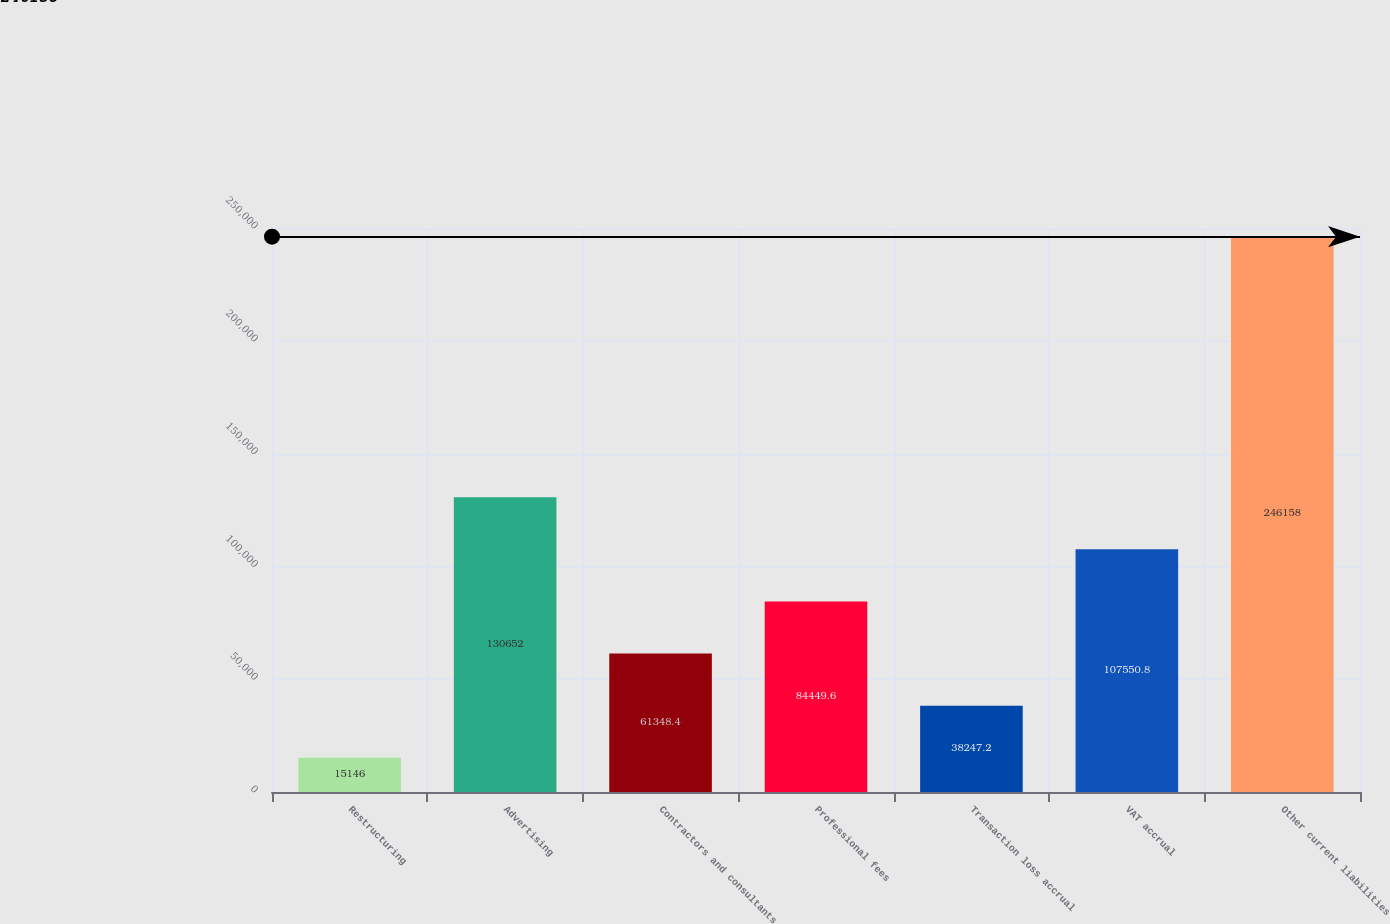Convert chart to OTSL. <chart><loc_0><loc_0><loc_500><loc_500><bar_chart><fcel>Restructuring<fcel>Advertising<fcel>Contractors and consultants<fcel>Professional fees<fcel>Transaction loss accrual<fcel>VAT accrual<fcel>Other current liabilities<nl><fcel>15146<fcel>130652<fcel>61348.4<fcel>84449.6<fcel>38247.2<fcel>107551<fcel>246158<nl></chart> 